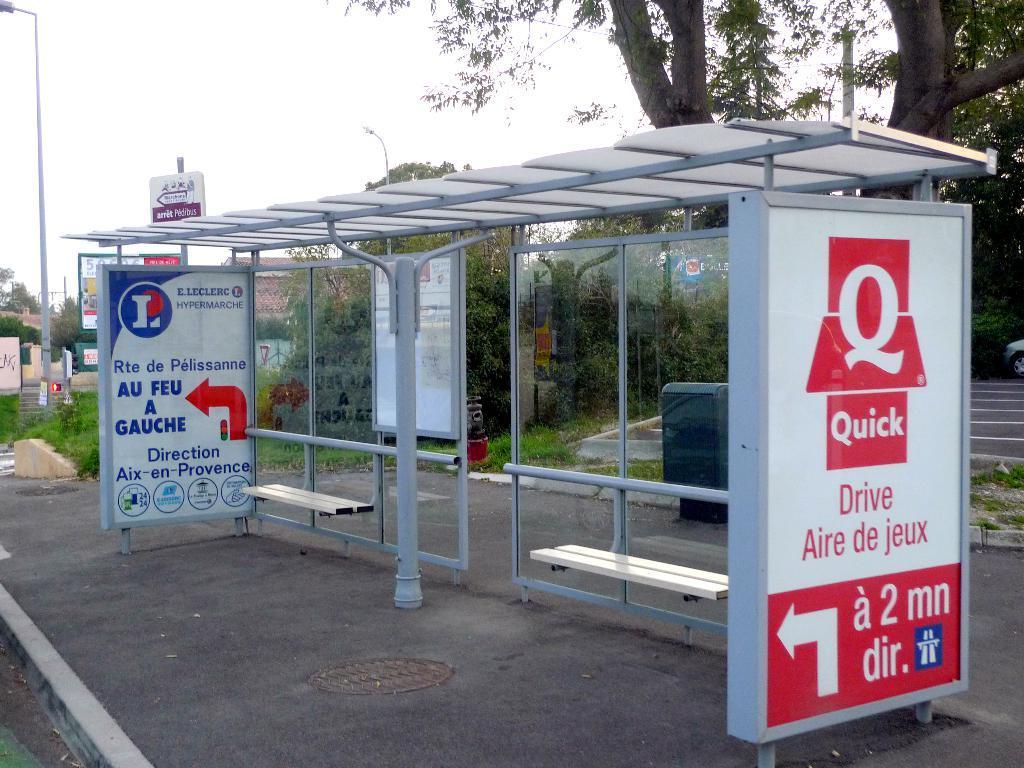In one or two sentences, can you explain what this image depicts? In this image I can see the side walk, few metal poles, few benches, and few banners on the side walk. In the background I can see few trees, few poles, a building and the sky. 